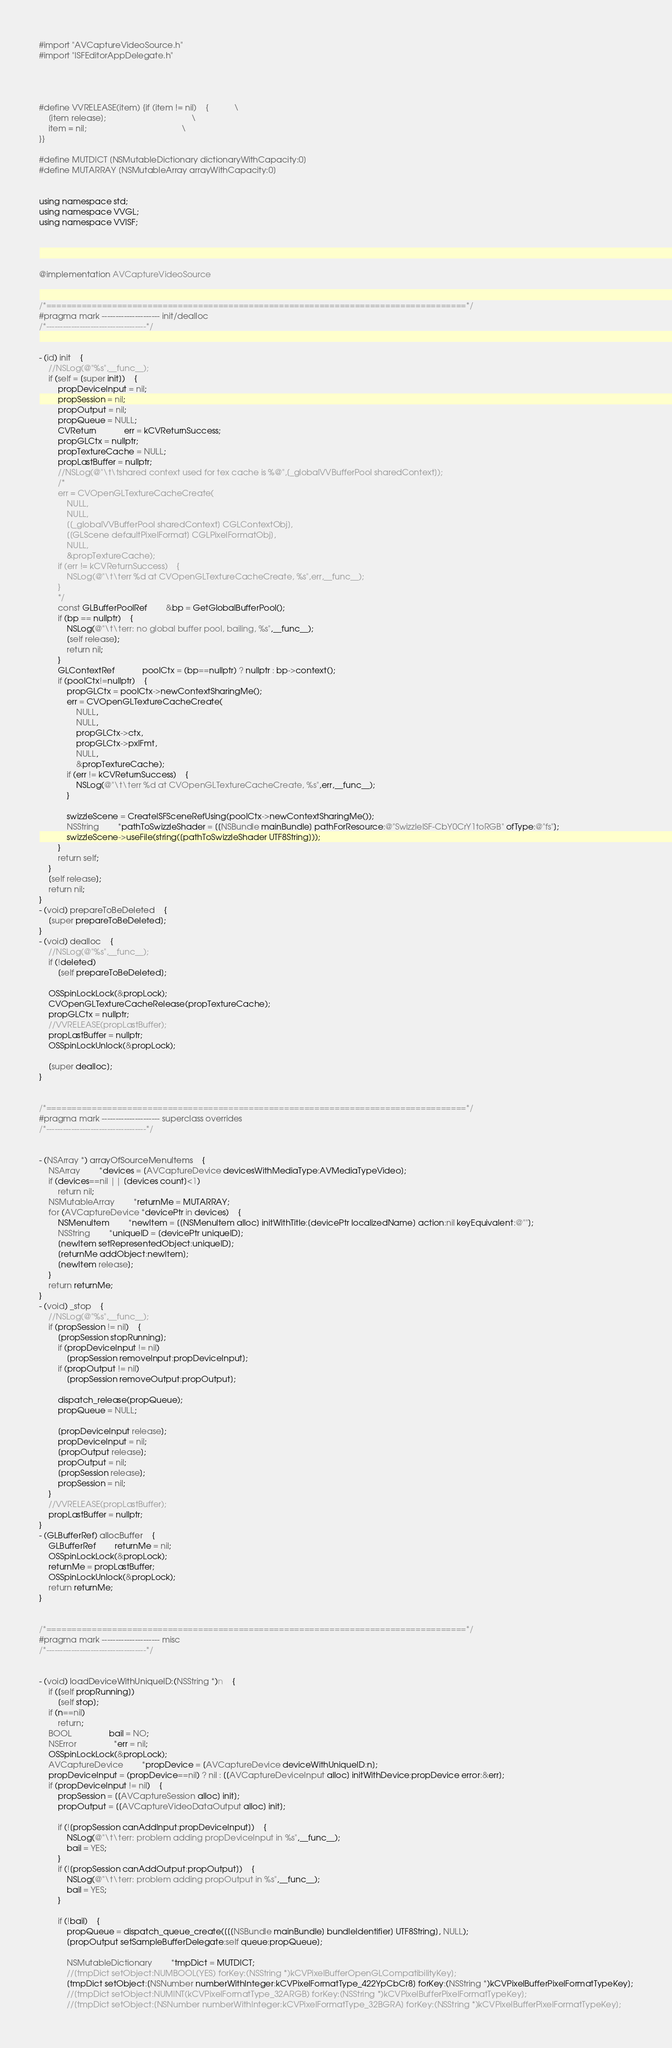<code> <loc_0><loc_0><loc_500><loc_500><_ObjectiveC_>#import "AVCaptureVideoSource.h"
#import "ISFEditorAppDelegate.h"




#define VVRELEASE(item) {if (item != nil)	{			\
	[item release];										\
	item = nil;											\
}}

#define MUTDICT [NSMutableDictionary dictionaryWithCapacity:0]
#define MUTARRAY [NSMutableArray arrayWithCapacity:0]


using namespace std;
using namespace VVGL;
using namespace VVISF;




@implementation AVCaptureVideoSource


/*===================================================================================*/
#pragma mark --------------------- init/dealloc
/*------------------------------------*/


- (id) init	{
	//NSLog(@"%s",__func__);
	if (self = [super init])	{
		propDeviceInput = nil;
		propSession = nil;
		propOutput = nil;
		propQueue = NULL;
		CVReturn			err = kCVReturnSuccess;
		propGLCtx = nullptr;
		propTextureCache = NULL;
		propLastBuffer = nullptr;
		//NSLog(@"\t\tshared context used for tex cache is %@",[_globalVVBufferPool sharedContext]);
		/*
		err = CVOpenGLTextureCacheCreate(
			NULL,
			NULL,
			[[_globalVVBufferPool sharedContext] CGLContextObj],
			[[GLScene defaultPixelFormat] CGLPixelFormatObj],
			NULL,
			&propTextureCache);
		if (err != kCVReturnSuccess)	{
			NSLog(@"\t\terr %d at CVOpenGLTextureCacheCreate, %s",err,__func__);
		}
		*/
		const GLBufferPoolRef		&bp = GetGlobalBufferPool();
		if (bp == nullptr)	{
			NSLog(@"\t\terr: no global buffer pool, bailing, %s",__func__);
			[self release];
			return nil;
		}
		GLContextRef			poolCtx = (bp==nullptr) ? nullptr : bp->context();
		if (poolCtx!=nullptr)	{
			propGLCtx = poolCtx->newContextSharingMe();
			err = CVOpenGLTextureCacheCreate(
				NULL,
				NULL,
				propGLCtx->ctx,
				propGLCtx->pxlFmt,
				NULL,
				&propTextureCache);
			if (err != kCVReturnSuccess)	{
				NSLog(@"\t\terr %d at CVOpenGLTextureCacheCreate, %s",err,__func__);
			}
			
			swizzleScene = CreateISFSceneRefUsing(poolCtx->newContextSharingMe());
			NSString		*pathToSwizzleShader = [[NSBundle mainBundle] pathForResource:@"SwizzleISF-CbY0CrY1toRGB" ofType:@"fs"];
			swizzleScene->useFile(string([pathToSwizzleShader UTF8String]));
		}
		return self;
	}
	[self release];
	return nil;
}
- (void) prepareToBeDeleted	{
	[super prepareToBeDeleted];
}
- (void) dealloc	{
	//NSLog(@"%s",__func__);
	if (!deleted)
		[self prepareToBeDeleted];
	
	OSSpinLockLock(&propLock);
	CVOpenGLTextureCacheRelease(propTextureCache);
	propGLCtx = nullptr;
	//VVRELEASE(propLastBuffer);
	propLastBuffer = nullptr;
	OSSpinLockUnlock(&propLock);
	
	[super dealloc];
}


/*===================================================================================*/
#pragma mark --------------------- superclass overrides
/*------------------------------------*/


- (NSArray *) arrayOfSourceMenuItems	{
	NSArray		*devices = [AVCaptureDevice devicesWithMediaType:AVMediaTypeVideo];
	if (devices==nil || [devices count]<1)
		return nil;
	NSMutableArray		*returnMe = MUTARRAY;
	for (AVCaptureDevice *devicePtr in devices)	{
		NSMenuItem		*newItem = [[NSMenuItem alloc] initWithTitle:[devicePtr localizedName] action:nil keyEquivalent:@""];
		NSString		*uniqueID = [devicePtr uniqueID];
		[newItem setRepresentedObject:uniqueID];
		[returnMe addObject:newItem];
		[newItem release];
	}
	return returnMe;
}
- (void) _stop	{
	//NSLog(@"%s",__func__);
	if (propSession != nil)	{
		[propSession stopRunning];
		if (propDeviceInput != nil)
			[propSession removeInput:propDeviceInput];
		if (propOutput != nil)
			[propSession removeOutput:propOutput];
		
		dispatch_release(propQueue);
		propQueue = NULL;
		
		[propDeviceInput release];
		propDeviceInput = nil;
		[propOutput release];
		propOutput = nil;
		[propSession release];
		propSession = nil;
	}
	//VVRELEASE(propLastBuffer);
	propLastBuffer = nullptr;
}
- (GLBufferRef) allocBuffer	{
	GLBufferRef		returnMe = nil;
	OSSpinLockLock(&propLock);
	returnMe = propLastBuffer;
	OSSpinLockUnlock(&propLock);
	return returnMe;
}


/*===================================================================================*/
#pragma mark --------------------- misc
/*------------------------------------*/


- (void) loadDeviceWithUniqueID:(NSString *)n	{
	if ([self propRunning])
		[self stop];
	if (n==nil)
		return;
	BOOL				bail = NO;
	NSError				*err = nil;
	OSSpinLockLock(&propLock);
	AVCaptureDevice		*propDevice = [AVCaptureDevice deviceWithUniqueID:n];
	propDeviceInput = (propDevice==nil) ? nil : [[AVCaptureDeviceInput alloc] initWithDevice:propDevice error:&err];
	if (propDeviceInput != nil)	{
		propSession = [[AVCaptureSession alloc] init];
		propOutput = [[AVCaptureVideoDataOutput alloc] init];
		
		if (![propSession canAddInput:propDeviceInput])	{
			NSLog(@"\t\terr: problem adding propDeviceInput in %s",__func__);
			bail = YES;
		}
		if (![propSession canAddOutput:propOutput])	{
			NSLog(@"\t\terr: problem adding propOutput in %s",__func__);
			bail = YES;
		}
		
		if (!bail)	{
			propQueue = dispatch_queue_create([[[NSBundle mainBundle] bundleIdentifier] UTF8String], NULL);
			[propOutput setSampleBufferDelegate:self queue:propQueue];
			
			NSMutableDictionary		*tmpDict = MUTDICT;
			//[tmpDict setObject:NUMBOOL(YES) forKey:(NSString *)kCVPixelBufferOpenGLCompatibilityKey];
			[tmpDict setObject:[NSNumber numberWithInteger:kCVPixelFormatType_422YpCbCr8] forKey:(NSString *)kCVPixelBufferPixelFormatTypeKey];
			//[tmpDict setObject:NUMINT(kCVPixelFormatType_32ARGB) forKey:(NSString *)kCVPixelBufferPixelFormatTypeKey];
			//[tmpDict setObject:[NSNumber numberWithInteger:kCVPixelFormatType_32BGRA] forKey:(NSString *)kCVPixelBufferPixelFormatTypeKey];</code> 